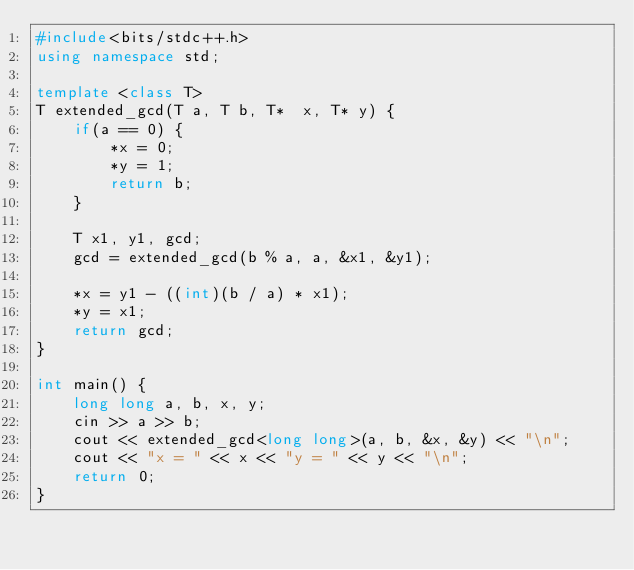<code> <loc_0><loc_0><loc_500><loc_500><_C++_>#include<bits/stdc++.h>
using namespace std;

template <class T>
T extended_gcd(T a, T b, T*  x, T* y) {
	if(a == 0) {
		*x = 0;
		*y = 1;
		return b;
	}

	T x1, y1, gcd;
	gcd = extended_gcd(b % a, a, &x1, &y1);

	*x = y1 - ((int)(b / a) * x1);
	*y = x1;
	return gcd;
}

int main() {
	long long a, b, x, y;
	cin >> a >> b;
	cout << extended_gcd<long long>(a, b, &x, &y) << "\n";
	cout << "x = " << x << "y = " << y << "\n";
	return 0;
}</code> 